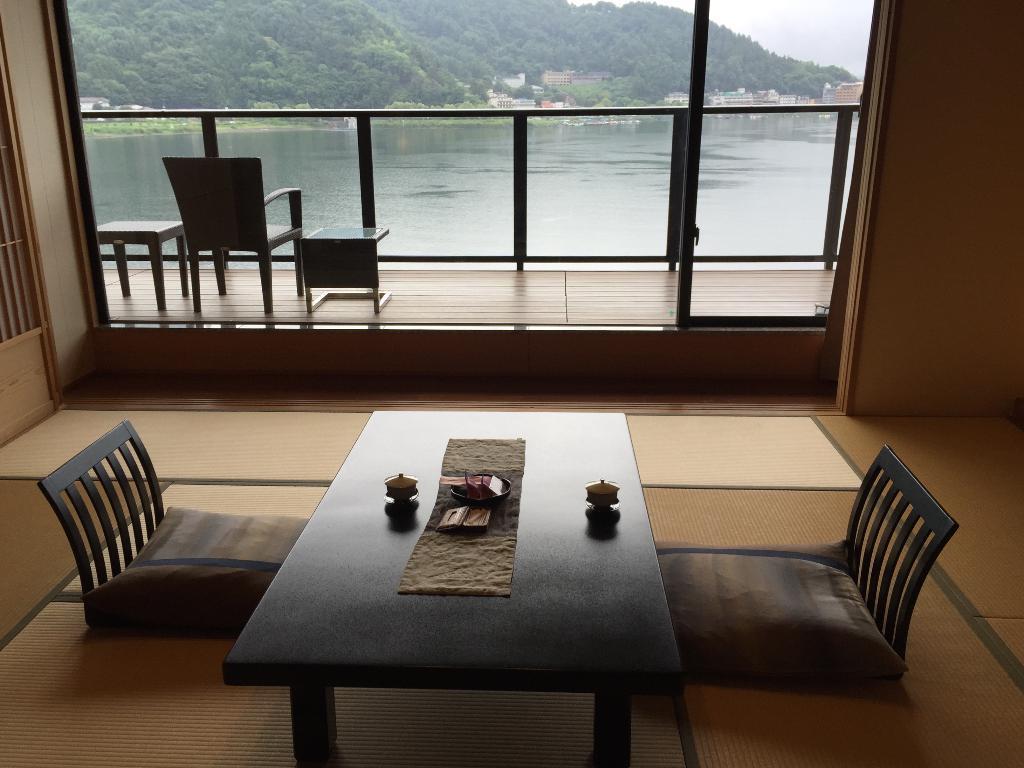How would you summarize this image in a sentence or two? This is clicked inside a building, there is dining table in the front with chairs on either side of it, in the back there are chairs on the balcony with a lake in front of it and over the background there is hill with trees all over it. 